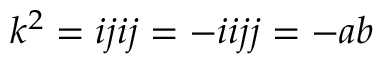<formula> <loc_0><loc_0><loc_500><loc_500>k ^ { 2 } = i j i j = - i i j j = - a b</formula> 